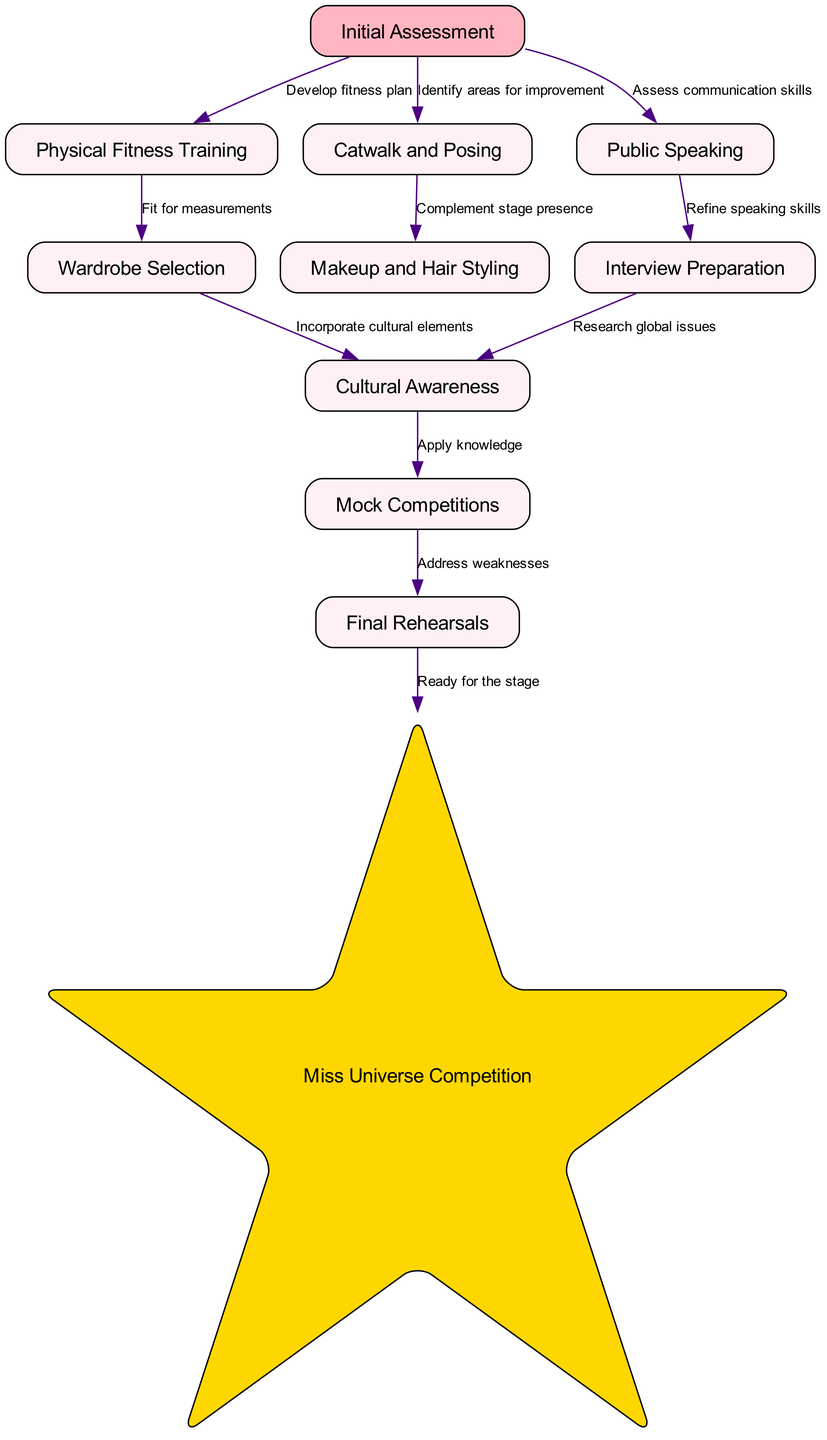What is the first step in the pageant contestant preparation process? The diagram indicates that the first step is "Initial Assessment" as it is the starting node in the flowchart.
Answer: Initial Assessment How many nodes are present in the flow chart? By counting all the distinct nodes listed in the data, there are 11 nodes total.
Answer: 11 Which training follows "Physical Fitness Training"? The edge from "Physical Fitness Training" leads to "Wardrobe Selection," indicating that this training follows "Physical Fitness Training."
Answer: Wardrobe Selection What is the last step before the Miss Universe Competition? The diagram shows that "Final Rehearsals" is directly connected to the "Miss Universe Competition," meaning it is the last step before the actual competition.
Answer: Final Rehearsals What does "Cultural Awareness" depend on in the preparation process? "Cultural Awareness" is dependent on both "Wardrobe Selection" and "Interview Preparation" as it connects from these nodes.
Answer: Wardrobe Selection, Interview Preparation How many edges are there in the flow chart? By counting the connections (edges) between the nodes in the diagram data, there are 10 edges present.
Answer: 10 What skill is assessed during "Initial Assessment"? The "Initial Assessment" specifically assesses "communication skills" as indicated by the edge leading to "Public Speaking."
Answer: communication skills What action is taken after "Mock Competitions"? The diagram shows that after "Mock Competitions," the next step is "Final Rehearsals," indicating the action to address weaknesses.
Answer: Final Rehearsals Which node is represented in a star shape? According to the diagram, "Miss Universe Competition" is represented in a star shape, highlighting its significance in the flow chart.
Answer: Miss Universe Competition 